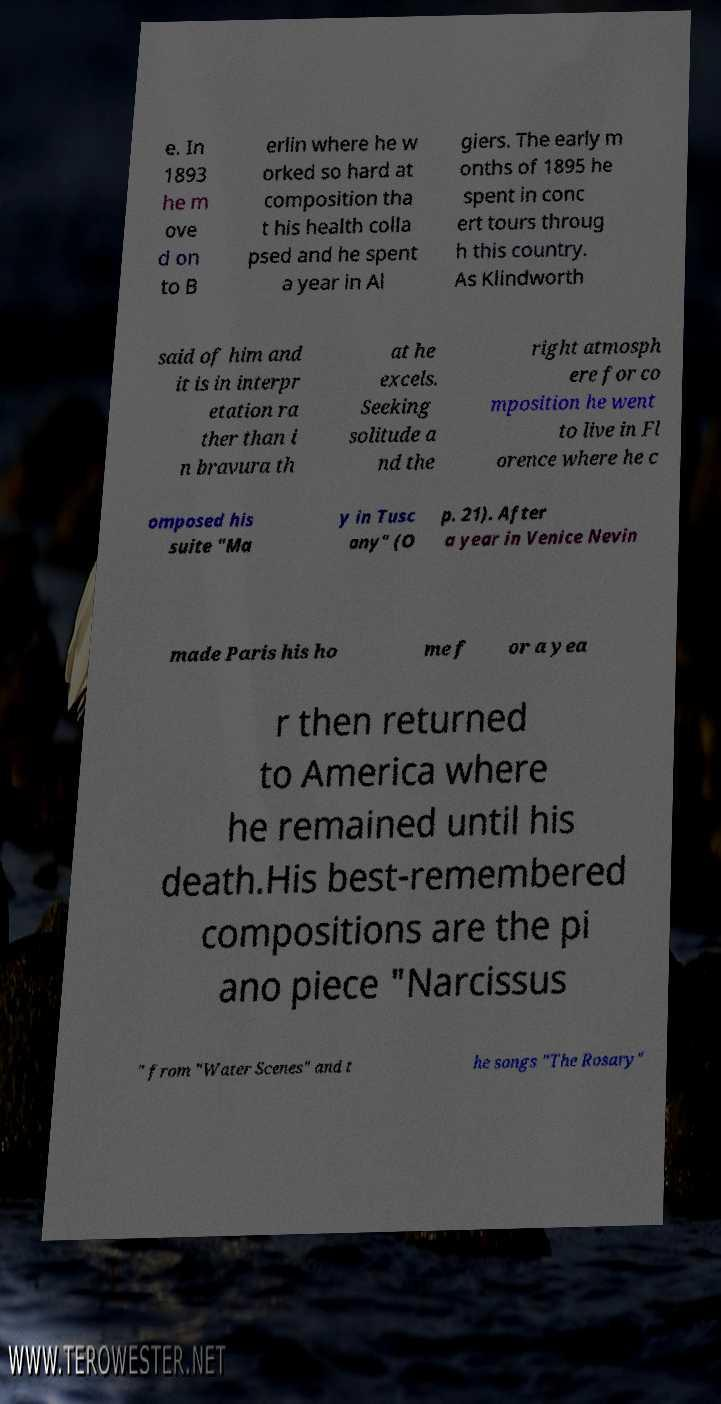There's text embedded in this image that I need extracted. Can you transcribe it verbatim? e. In 1893 he m ove d on to B erlin where he w orked so hard at composition tha t his health colla psed and he spent a year in Al giers. The early m onths of 1895 he spent in conc ert tours throug h this country. As Klindworth said of him and it is in interpr etation ra ther than i n bravura th at he excels. Seeking solitude a nd the right atmosph ere for co mposition he went to live in Fl orence where he c omposed his suite "Ma y in Tusc any" (O p. 21). After a year in Venice Nevin made Paris his ho me f or a yea r then returned to America where he remained until his death.His best-remembered compositions are the pi ano piece "Narcissus " from "Water Scenes" and t he songs "The Rosary" 